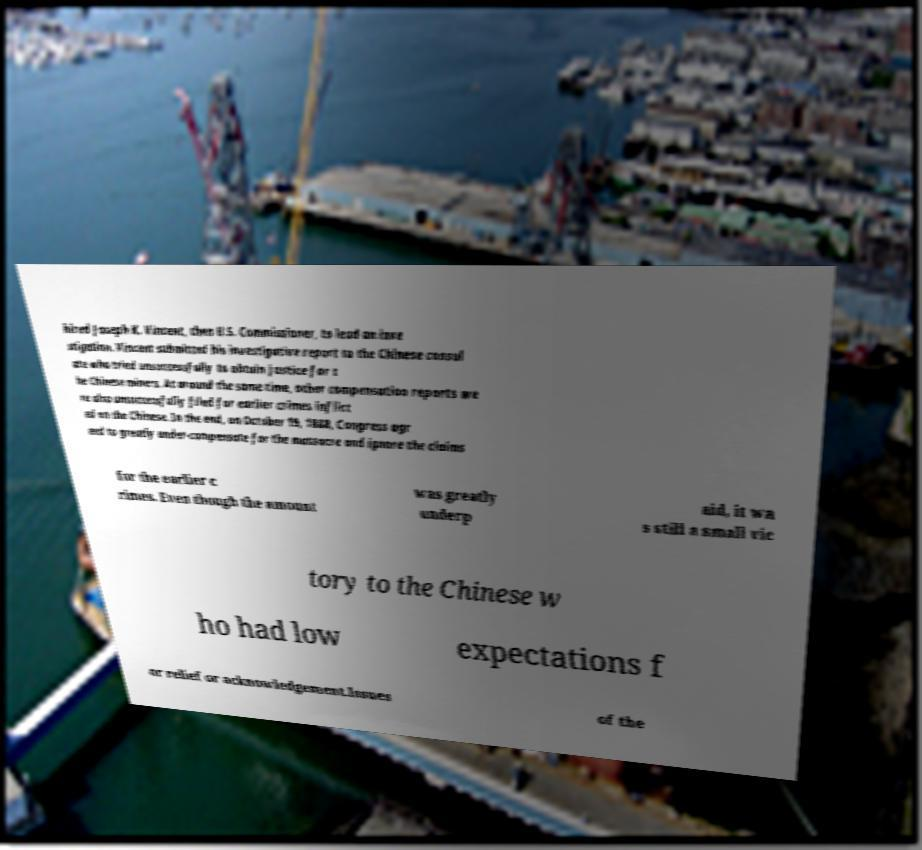What messages or text are displayed in this image? I need them in a readable, typed format. hired Joseph K. Vincent, then U.S. Commissioner, to lead an inve stigation. Vincent submitted his investigative report to the Chinese consul ate who tried unsuccessfully to obtain justice for t he Chinese miners. At around the same time, other compensation reports we re also unsuccessfully filed for earlier crimes inflict ed on the Chinese. In the end, on October 19, 1888, Congress agr eed to greatly under-compensate for the massacre and ignore the claims for the earlier c rimes. Even though the amount was greatly underp aid, it wa s still a small vic tory to the Chinese w ho had low expectations f or relief or acknowledgement.Issues of the 